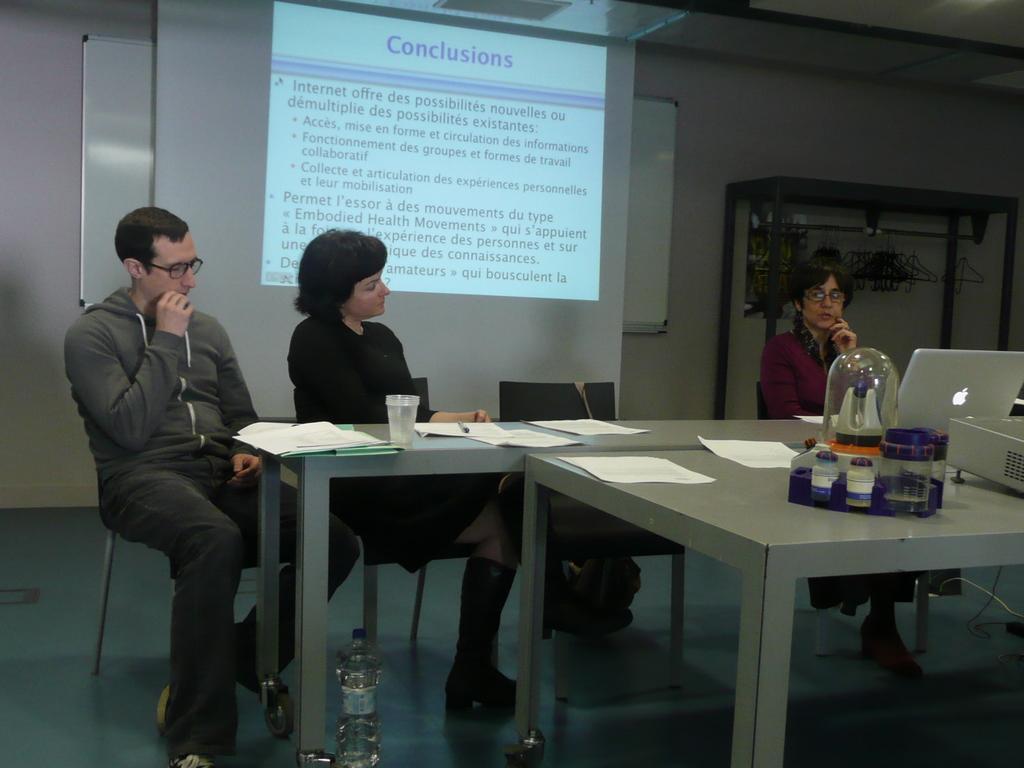In one or two sentences, can you explain what this image depicts? In the image there are total three people sitting in front of a table there are also few papers and laptop and some other bottle on the table, in the back side there is a presentation being displayed in the background there is a white color board and a wall. 